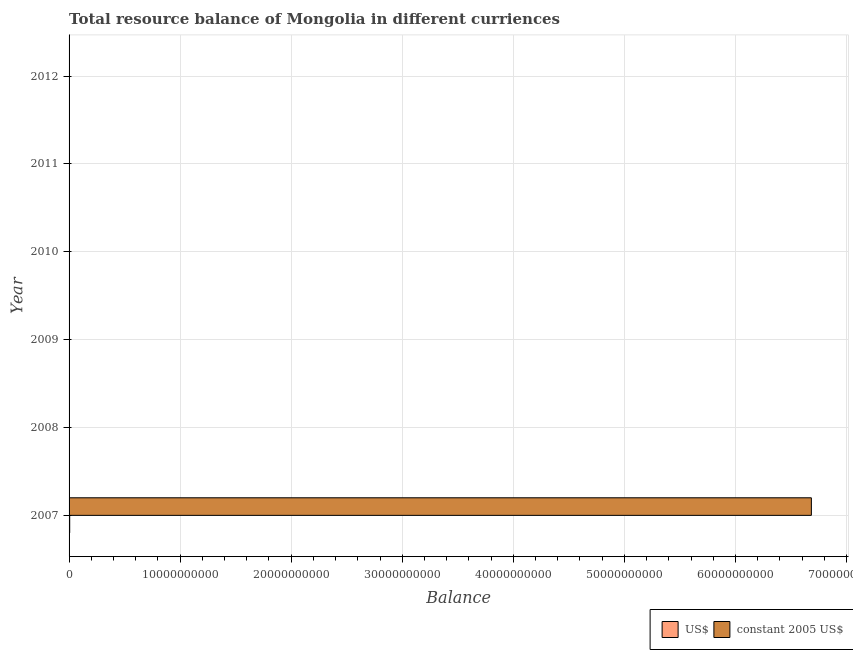Are the number of bars per tick equal to the number of legend labels?
Make the answer very short. No. Are the number of bars on each tick of the Y-axis equal?
Make the answer very short. No. In how many cases, is the number of bars for a given year not equal to the number of legend labels?
Give a very brief answer. 5. Across all years, what is the maximum resource balance in us$?
Give a very brief answer. 5.71e+07. What is the total resource balance in constant us$ in the graph?
Keep it short and to the point. 6.68e+1. What is the average resource balance in constant us$ per year?
Give a very brief answer. 1.11e+1. In the year 2007, what is the difference between the resource balance in constant us$ and resource balance in us$?
Keep it short and to the point. 6.68e+1. In how many years, is the resource balance in us$ greater than 34000000000 units?
Offer a very short reply. 0. What is the difference between the highest and the lowest resource balance in constant us$?
Provide a succinct answer. 6.68e+1. In how many years, is the resource balance in us$ greater than the average resource balance in us$ taken over all years?
Your response must be concise. 1. Are all the bars in the graph horizontal?
Give a very brief answer. Yes. Are the values on the major ticks of X-axis written in scientific E-notation?
Provide a short and direct response. No. Does the graph contain any zero values?
Provide a short and direct response. Yes. Does the graph contain grids?
Keep it short and to the point. Yes. Where does the legend appear in the graph?
Provide a short and direct response. Bottom right. How many legend labels are there?
Your answer should be compact. 2. What is the title of the graph?
Your answer should be compact. Total resource balance of Mongolia in different curriences. What is the label or title of the X-axis?
Give a very brief answer. Balance. What is the label or title of the Y-axis?
Offer a very short reply. Year. What is the Balance in US$ in 2007?
Provide a short and direct response. 5.71e+07. What is the Balance of constant 2005 US$ in 2007?
Your answer should be very brief. 6.68e+1. What is the Balance in constant 2005 US$ in 2008?
Your answer should be compact. 0. What is the Balance in constant 2005 US$ in 2009?
Provide a succinct answer. 0. What is the Balance in constant 2005 US$ in 2010?
Provide a succinct answer. 0. What is the Balance in US$ in 2011?
Your answer should be compact. 0. What is the Balance of constant 2005 US$ in 2011?
Your answer should be very brief. 0. Across all years, what is the maximum Balance of US$?
Offer a terse response. 5.71e+07. Across all years, what is the maximum Balance of constant 2005 US$?
Provide a short and direct response. 6.68e+1. What is the total Balance of US$ in the graph?
Offer a terse response. 5.71e+07. What is the total Balance of constant 2005 US$ in the graph?
Offer a very short reply. 6.68e+1. What is the average Balance in US$ per year?
Ensure brevity in your answer.  9.52e+06. What is the average Balance of constant 2005 US$ per year?
Your response must be concise. 1.11e+1. In the year 2007, what is the difference between the Balance of US$ and Balance of constant 2005 US$?
Your answer should be very brief. -6.68e+1. What is the difference between the highest and the lowest Balance in US$?
Keep it short and to the point. 5.71e+07. What is the difference between the highest and the lowest Balance in constant 2005 US$?
Provide a succinct answer. 6.68e+1. 